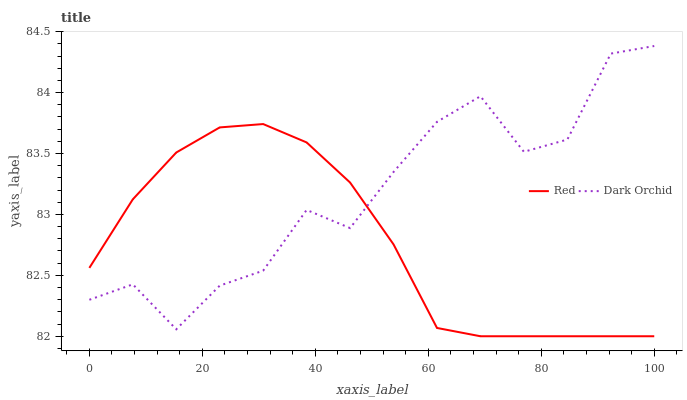Does Red have the minimum area under the curve?
Answer yes or no. Yes. Does Dark Orchid have the maximum area under the curve?
Answer yes or no. Yes. Does Red have the maximum area under the curve?
Answer yes or no. No. Is Red the smoothest?
Answer yes or no. Yes. Is Dark Orchid the roughest?
Answer yes or no. Yes. Is Red the roughest?
Answer yes or no. No. Does Dark Orchid have the highest value?
Answer yes or no. Yes. Does Red have the highest value?
Answer yes or no. No. 